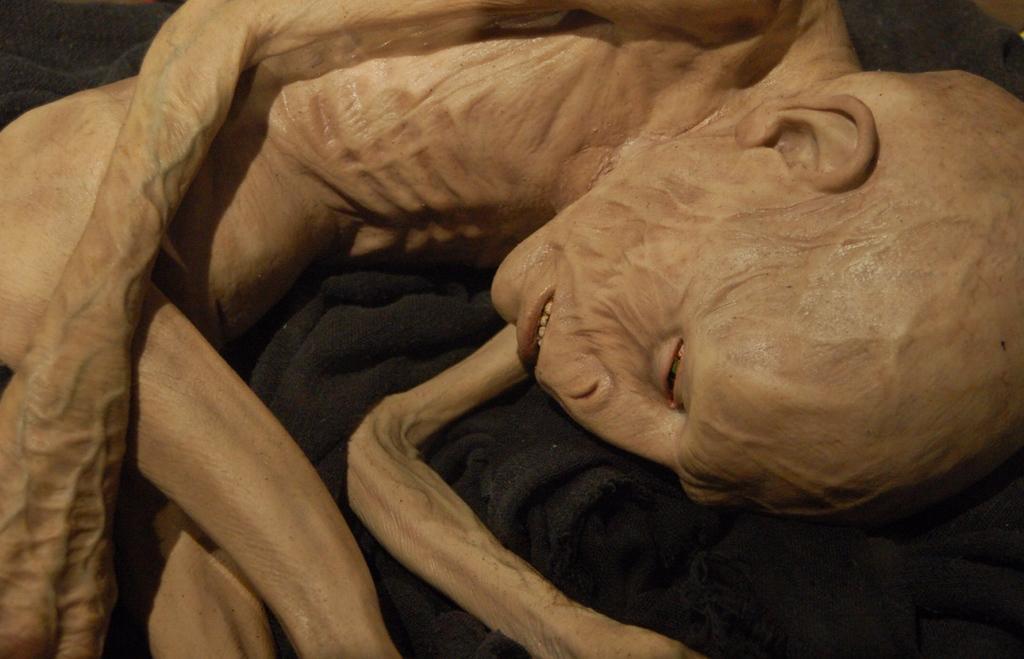Could you give a brief overview of what you see in this image? This picture shows a diseased human and we see a black cloth. 